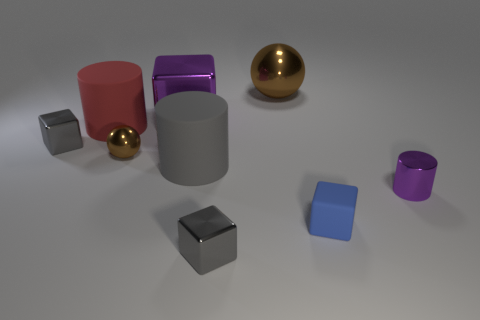What is the size of the other metal thing that is the same shape as the tiny brown metal object?
Your response must be concise. Large. What number of large brown things have the same material as the large gray object?
Give a very brief answer. 0. Is the material of the brown ball in front of the red object the same as the large red object?
Provide a succinct answer. No. Are there the same number of big rubber objects that are behind the purple cube and brown shiny balls?
Your answer should be compact. No. What is the size of the matte block?
Keep it short and to the point. Small. There is a thing that is the same color as the large shiny block; what is it made of?
Your answer should be compact. Metal. How many other metal cylinders have the same color as the small metallic cylinder?
Give a very brief answer. 0. Do the gray matte cylinder and the metallic cylinder have the same size?
Keep it short and to the point. No. There is a metallic block that is in front of the purple thing that is right of the blue thing; how big is it?
Make the answer very short. Small. Does the rubber cube have the same color as the tiny metallic thing in front of the small purple thing?
Offer a terse response. No. 